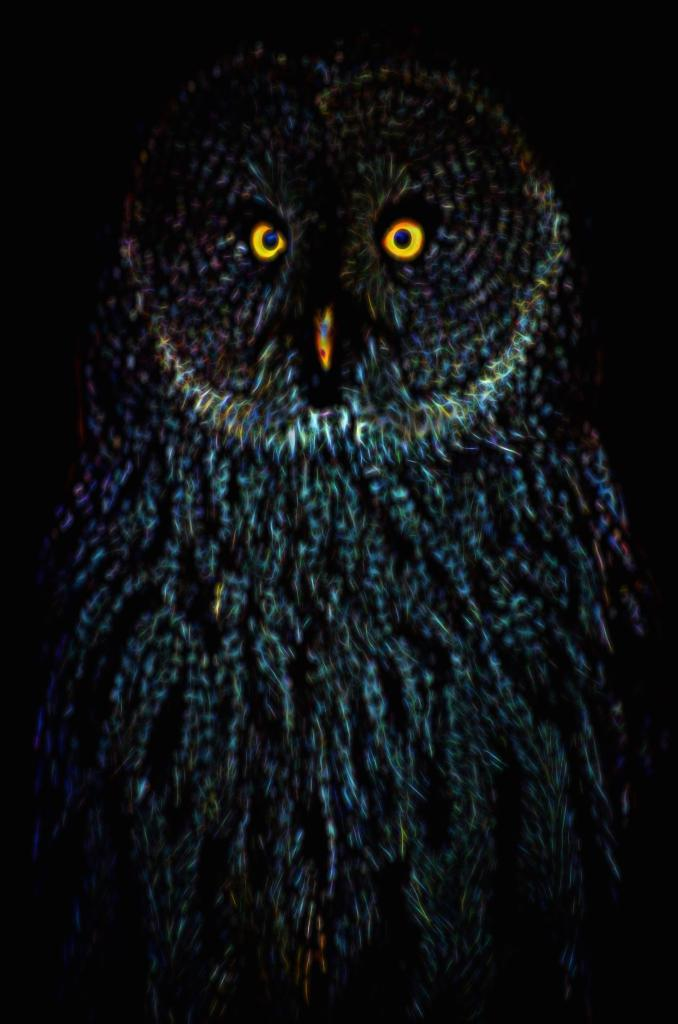What type of animal is in the image? There is an owl in the image. What colors can be seen on the owl? The owl has blue, white, and black colors. What color is the background of the image? The background of the image is black. How many buttons can be seen on the owl in the image? There are no buttons present on the owl in the image. What type of currency is visible in the image? There is no currency, such as a dime, present in the image. 